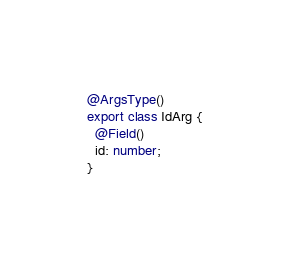Convert code to text. <code><loc_0><loc_0><loc_500><loc_500><_TypeScript_>
@ArgsType()
export class IdArg {
  @Field()
  id: number;
}
</code> 